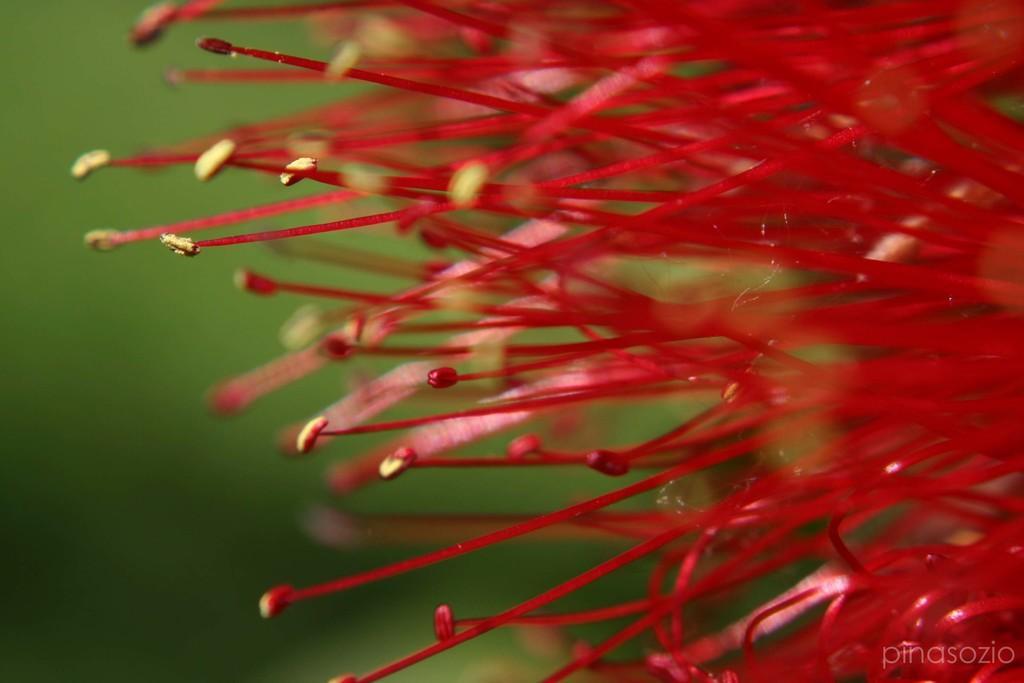Can you describe this image briefly? There are red color stamens. In the background it is green and blurred. On the right corner there is a watermark. 